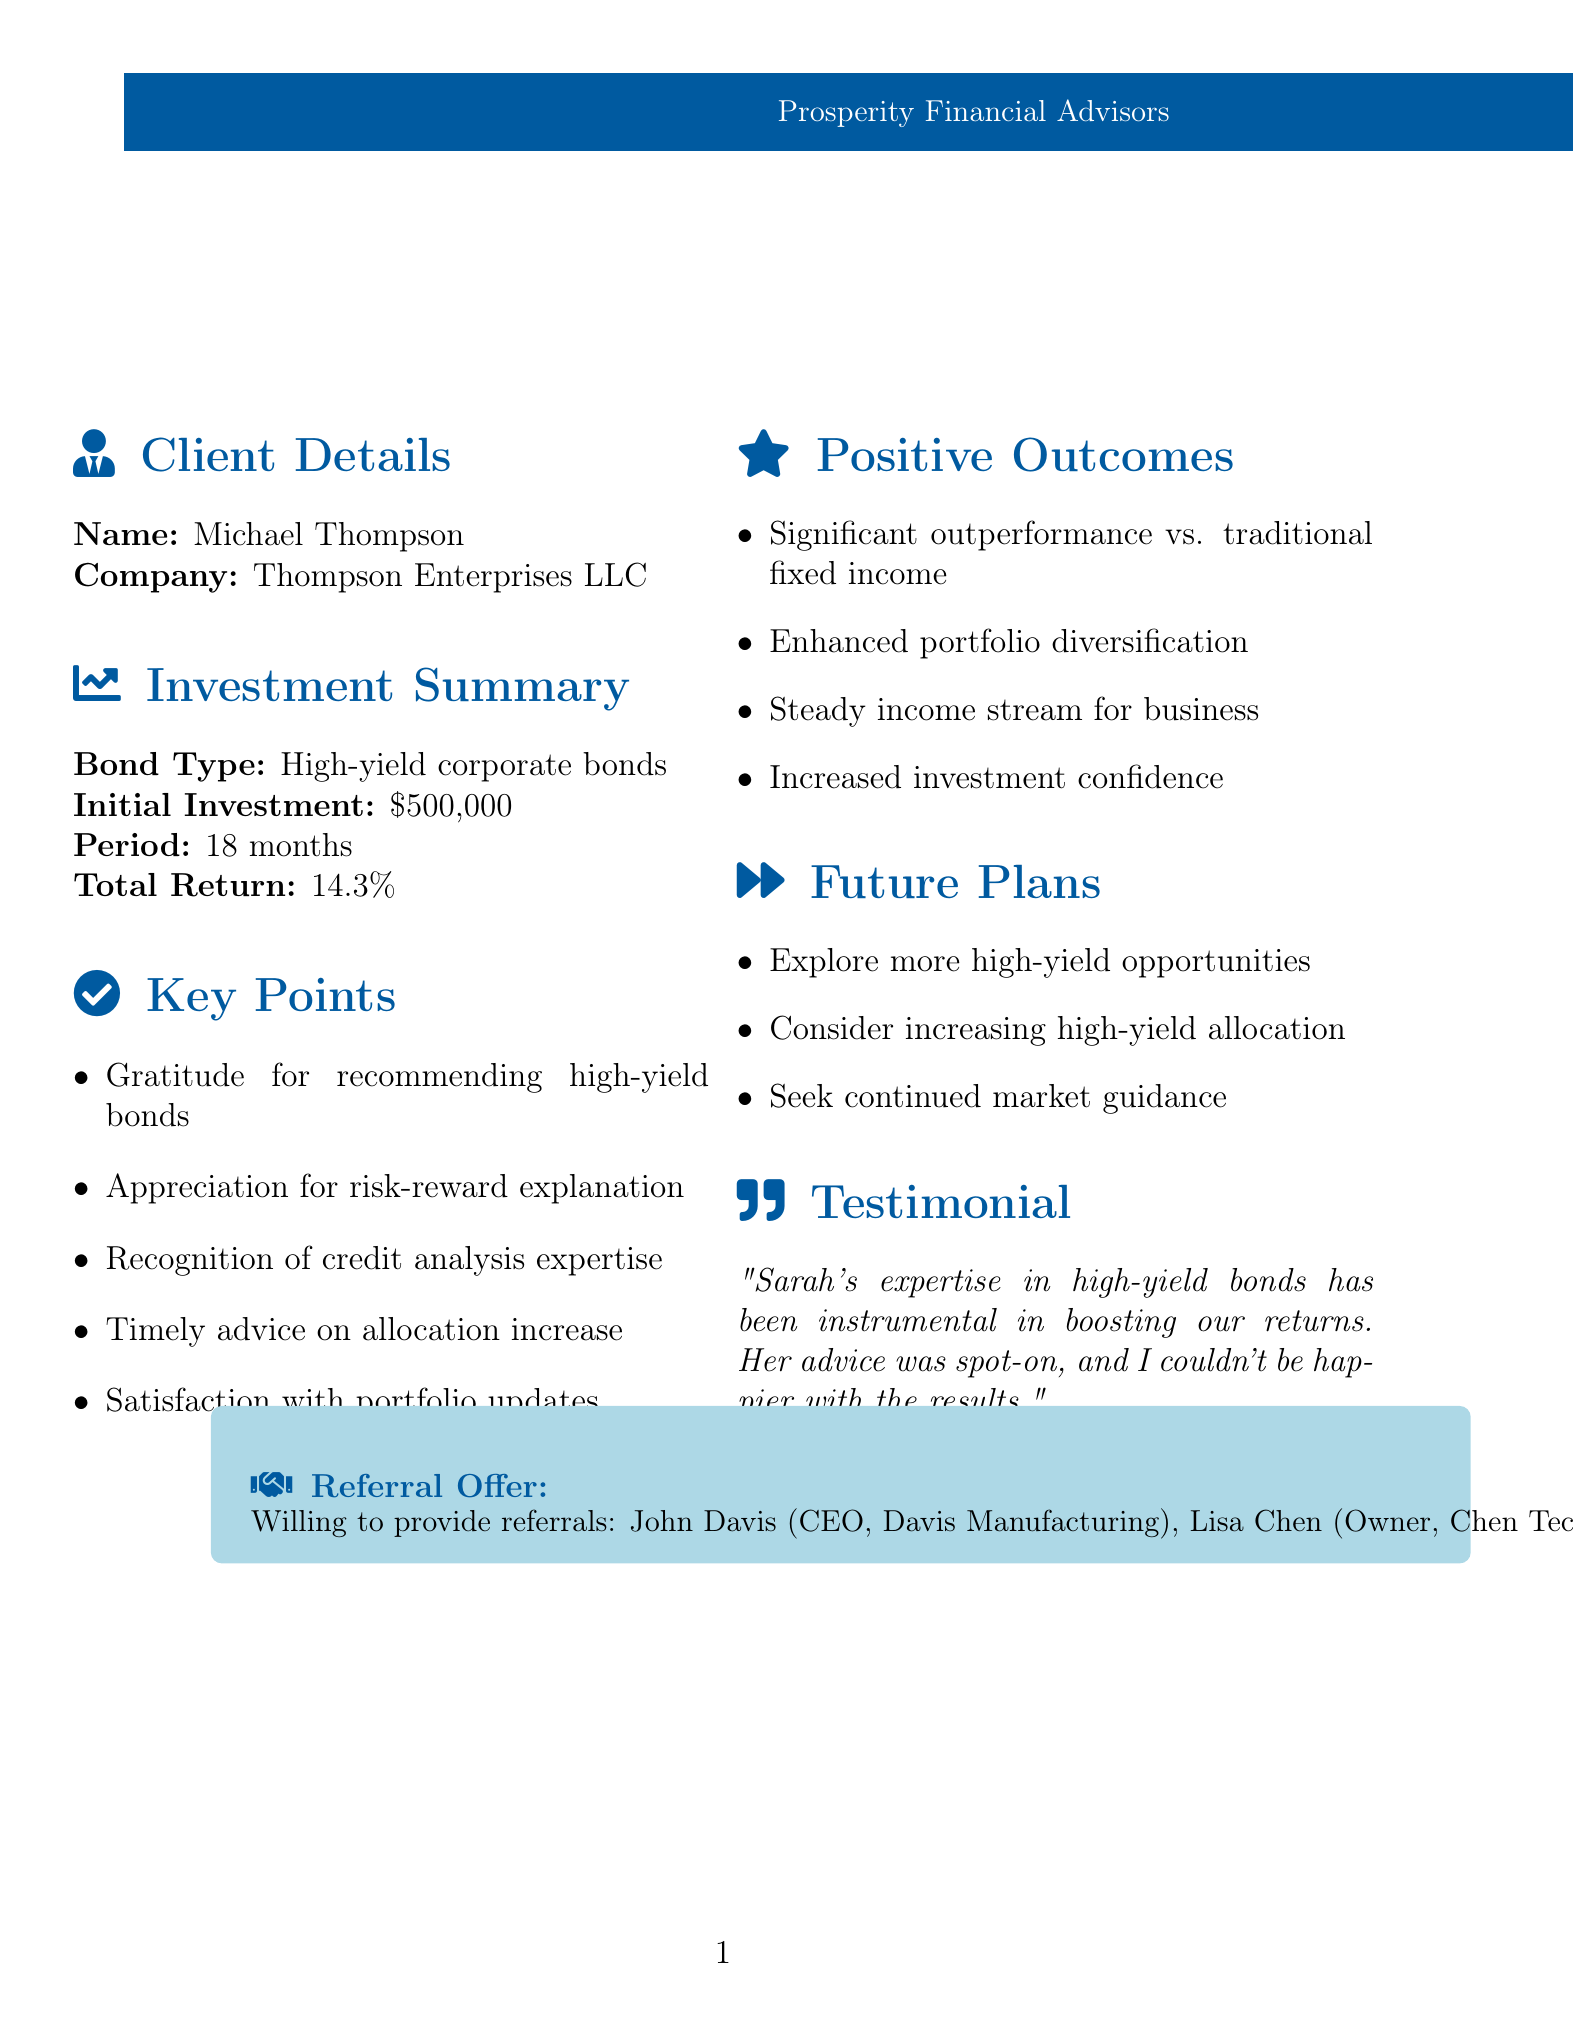What is the name of the client? The name of the client is mentioned in the document as Michael Thompson.
Answer: Michael Thompson What is the total return on the investment? The total return is explicitly stated under the Investment Summary section as 14.3%.
Answer: 14.3% What is the initial investment amount? The initial investment amount is clearly mentioned as $500,000 in the Investment Summary.
Answer: $500,000 Which bond had the highest interest rate? The testimonial mentions three specific bonds, and the bond with the highest rate is Occidental Petroleum 6.625% 2030, which is the highest percentage among those listed.
Answer: Occidental Petroleum 6.625% 2030 How long was the investment period? The document states the investment period is 18 months, found in the Investment Summary section.
Answer: 18 months What did the client express gratitude for in the letter? The client expressed gratitude for recommending high-yield bonds during market volatility, which is one of the key points outlined.
Answer: Recommending high-yield bonds What future plans does Michael Thompson have regarding investments? The future plans mentioned include exploring other high-yield opportunities, which is part of the Future Plans section.
Answer: Exploring more high-yield opportunities Who is the advisor mentioned in the letter? The advisor's name is noted as Sarah Williams throughout the document.
Answer: Sarah Williams What kind of bonds did the client invest in? The bonds the client invested in are categorized as high-yield corporate bonds in the Investment Summary.
Answer: High-yield corporate bonds 